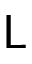<formula> <loc_0><loc_0><loc_500><loc_500>L</formula> 